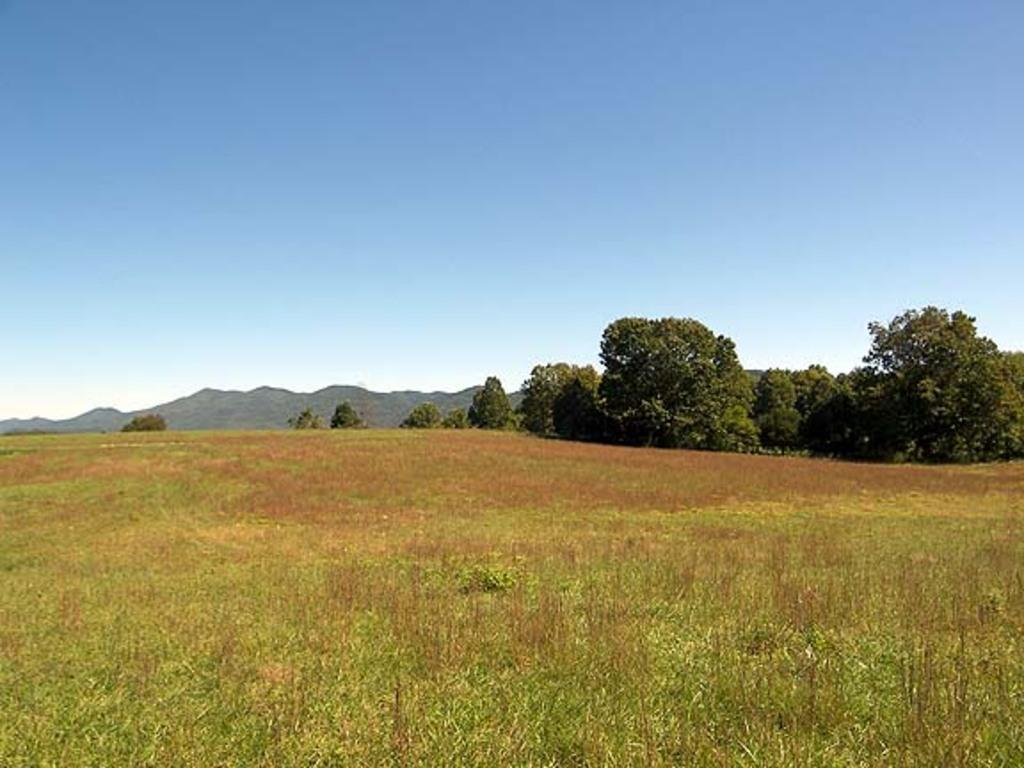What type of surface is visible in the image? There is a grass surface in the image. What can be found on the grass surface? There are plants on the grass surface. What other natural elements are visible in the image? There are trees and hills visible in the image. What is the color of the sky in the image? The sky is blue in color and visible in the image. Where is the book placed on the grass surface in the image? There is no book present in the image; it only features a grass surface, plants, trees, hills, and a blue sky. 